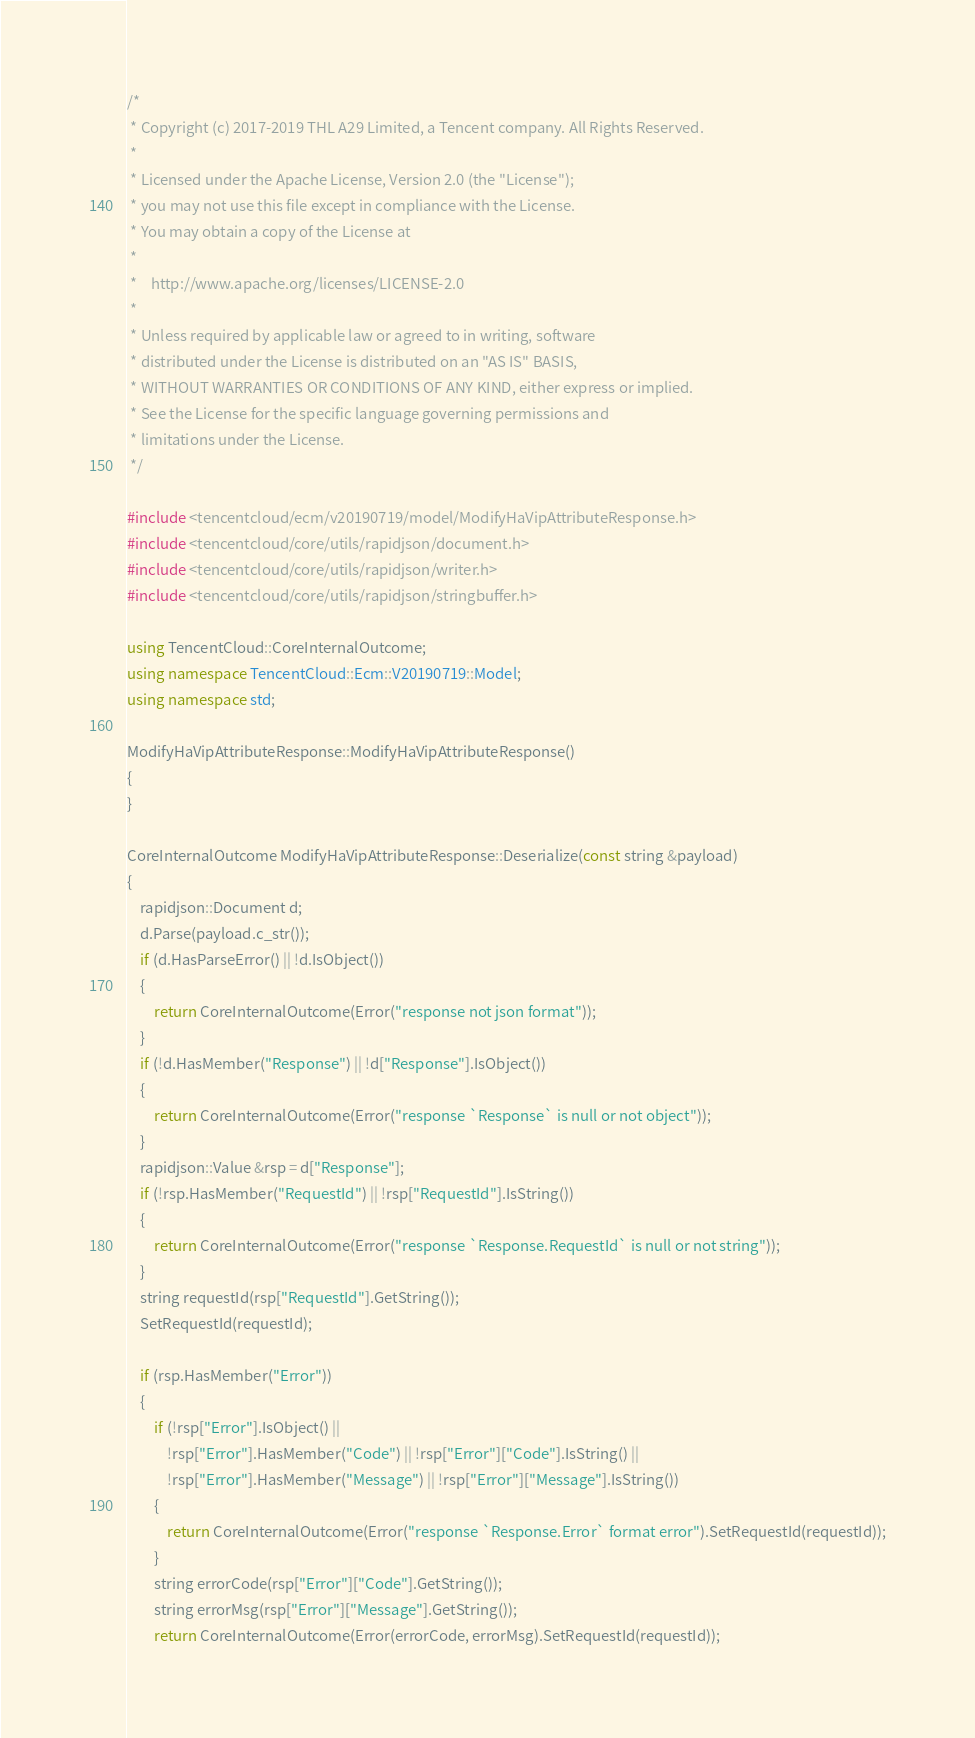Convert code to text. <code><loc_0><loc_0><loc_500><loc_500><_C++_>/*
 * Copyright (c) 2017-2019 THL A29 Limited, a Tencent company. All Rights Reserved.
 *
 * Licensed under the Apache License, Version 2.0 (the "License");
 * you may not use this file except in compliance with the License.
 * You may obtain a copy of the License at
 *
 *    http://www.apache.org/licenses/LICENSE-2.0
 *
 * Unless required by applicable law or agreed to in writing, software
 * distributed under the License is distributed on an "AS IS" BASIS,
 * WITHOUT WARRANTIES OR CONDITIONS OF ANY KIND, either express or implied.
 * See the License for the specific language governing permissions and
 * limitations under the License.
 */

#include <tencentcloud/ecm/v20190719/model/ModifyHaVipAttributeResponse.h>
#include <tencentcloud/core/utils/rapidjson/document.h>
#include <tencentcloud/core/utils/rapidjson/writer.h>
#include <tencentcloud/core/utils/rapidjson/stringbuffer.h>

using TencentCloud::CoreInternalOutcome;
using namespace TencentCloud::Ecm::V20190719::Model;
using namespace std;

ModifyHaVipAttributeResponse::ModifyHaVipAttributeResponse()
{
}

CoreInternalOutcome ModifyHaVipAttributeResponse::Deserialize(const string &payload)
{
    rapidjson::Document d;
    d.Parse(payload.c_str());
    if (d.HasParseError() || !d.IsObject())
    {
        return CoreInternalOutcome(Error("response not json format"));
    }
    if (!d.HasMember("Response") || !d["Response"].IsObject())
    {
        return CoreInternalOutcome(Error("response `Response` is null or not object"));
    }
    rapidjson::Value &rsp = d["Response"];
    if (!rsp.HasMember("RequestId") || !rsp["RequestId"].IsString())
    {
        return CoreInternalOutcome(Error("response `Response.RequestId` is null or not string"));
    }
    string requestId(rsp["RequestId"].GetString());
    SetRequestId(requestId);

    if (rsp.HasMember("Error"))
    {
        if (!rsp["Error"].IsObject() ||
            !rsp["Error"].HasMember("Code") || !rsp["Error"]["Code"].IsString() ||
            !rsp["Error"].HasMember("Message") || !rsp["Error"]["Message"].IsString())
        {
            return CoreInternalOutcome(Error("response `Response.Error` format error").SetRequestId(requestId));
        }
        string errorCode(rsp["Error"]["Code"].GetString());
        string errorMsg(rsp["Error"]["Message"].GetString());
        return CoreInternalOutcome(Error(errorCode, errorMsg).SetRequestId(requestId));</code> 